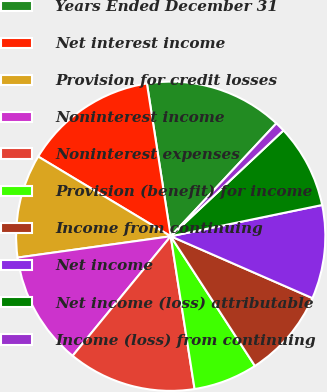<chart> <loc_0><loc_0><loc_500><loc_500><pie_chart><fcel>Years Ended December 31<fcel>Net interest income<fcel>Provision for credit losses<fcel>Noninterest income<fcel>Noninterest expenses<fcel>Provision (benefit) for income<fcel>Income from continuing<fcel>Net income<fcel>Net income (loss) attributable<fcel>Income (loss) from continuing<nl><fcel>14.43%<fcel>13.92%<fcel>10.82%<fcel>11.86%<fcel>13.4%<fcel>6.7%<fcel>9.28%<fcel>9.79%<fcel>8.76%<fcel>1.03%<nl></chart> 